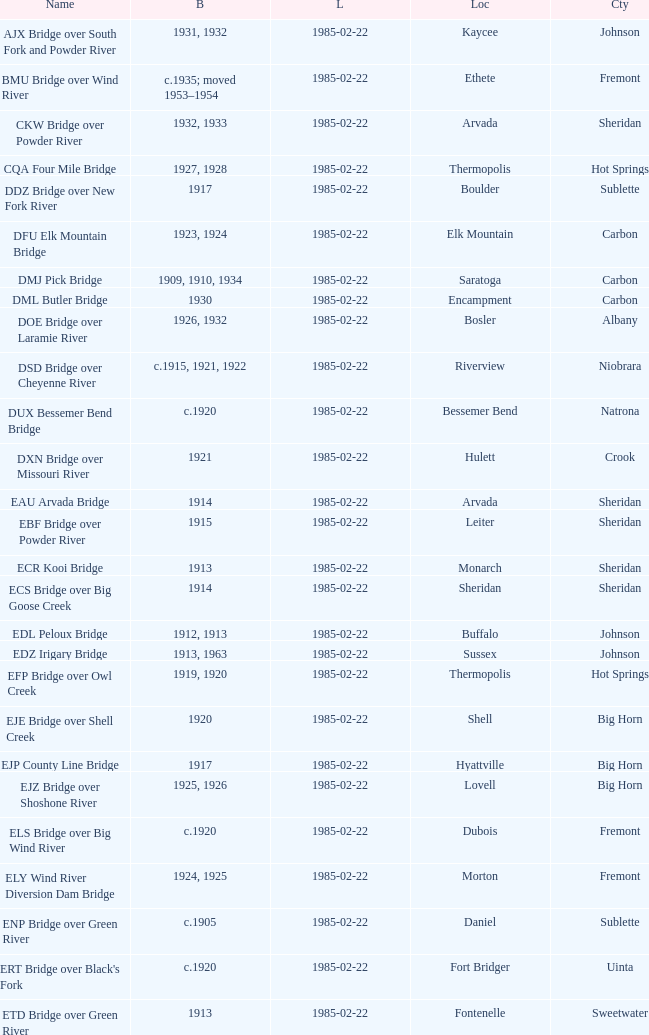Would you be able to parse every entry in this table? {'header': ['Name', 'B', 'L', 'Loc', 'Cty'], 'rows': [['AJX Bridge over South Fork and Powder River', '1931, 1932', '1985-02-22', 'Kaycee', 'Johnson'], ['BMU Bridge over Wind River', 'c.1935; moved 1953–1954', '1985-02-22', 'Ethete', 'Fremont'], ['CKW Bridge over Powder River', '1932, 1933', '1985-02-22', 'Arvada', 'Sheridan'], ['CQA Four Mile Bridge', '1927, 1928', '1985-02-22', 'Thermopolis', 'Hot Springs'], ['DDZ Bridge over New Fork River', '1917', '1985-02-22', 'Boulder', 'Sublette'], ['DFU Elk Mountain Bridge', '1923, 1924', '1985-02-22', 'Elk Mountain', 'Carbon'], ['DMJ Pick Bridge', '1909, 1910, 1934', '1985-02-22', 'Saratoga', 'Carbon'], ['DML Butler Bridge', '1930', '1985-02-22', 'Encampment', 'Carbon'], ['DOE Bridge over Laramie River', '1926, 1932', '1985-02-22', 'Bosler', 'Albany'], ['DSD Bridge over Cheyenne River', 'c.1915, 1921, 1922', '1985-02-22', 'Riverview', 'Niobrara'], ['DUX Bessemer Bend Bridge', 'c.1920', '1985-02-22', 'Bessemer Bend', 'Natrona'], ['DXN Bridge over Missouri River', '1921', '1985-02-22', 'Hulett', 'Crook'], ['EAU Arvada Bridge', '1914', '1985-02-22', 'Arvada', 'Sheridan'], ['EBF Bridge over Powder River', '1915', '1985-02-22', 'Leiter', 'Sheridan'], ['ECR Kooi Bridge', '1913', '1985-02-22', 'Monarch', 'Sheridan'], ['ECS Bridge over Big Goose Creek', '1914', '1985-02-22', 'Sheridan', 'Sheridan'], ['EDL Peloux Bridge', '1912, 1913', '1985-02-22', 'Buffalo', 'Johnson'], ['EDZ Irigary Bridge', '1913, 1963', '1985-02-22', 'Sussex', 'Johnson'], ['EFP Bridge over Owl Creek', '1919, 1920', '1985-02-22', 'Thermopolis', 'Hot Springs'], ['EJE Bridge over Shell Creek', '1920', '1985-02-22', 'Shell', 'Big Horn'], ['EJP County Line Bridge', '1917', '1985-02-22', 'Hyattville', 'Big Horn'], ['EJZ Bridge over Shoshone River', '1925, 1926', '1985-02-22', 'Lovell', 'Big Horn'], ['ELS Bridge over Big Wind River', 'c.1920', '1985-02-22', 'Dubois', 'Fremont'], ['ELY Wind River Diversion Dam Bridge', '1924, 1925', '1985-02-22', 'Morton', 'Fremont'], ['ENP Bridge over Green River', 'c.1905', '1985-02-22', 'Daniel', 'Sublette'], ["ERT Bridge over Black's Fork", 'c.1920', '1985-02-22', 'Fort Bridger', 'Uinta'], ['ETD Bridge over Green River', '1913', '1985-02-22', 'Fontenelle', 'Sweetwater'], ['ETR Big Island Bridge', '1909, 1910', '1985-02-22', 'Green River', 'Sweetwater'], ['EWZ Bridge over East Channel of Laramie River', '1913, 1914', '1985-02-22', 'Wheatland', 'Platte'], ['Hayden Arch Bridge', '1924, 1925', '1985-02-22', 'Cody', 'Park'], ['Rairden Bridge', '1916', '1985-02-22', 'Manderson', 'Big Horn']]} What is the county of the bridge in Boulder? Sublette. 